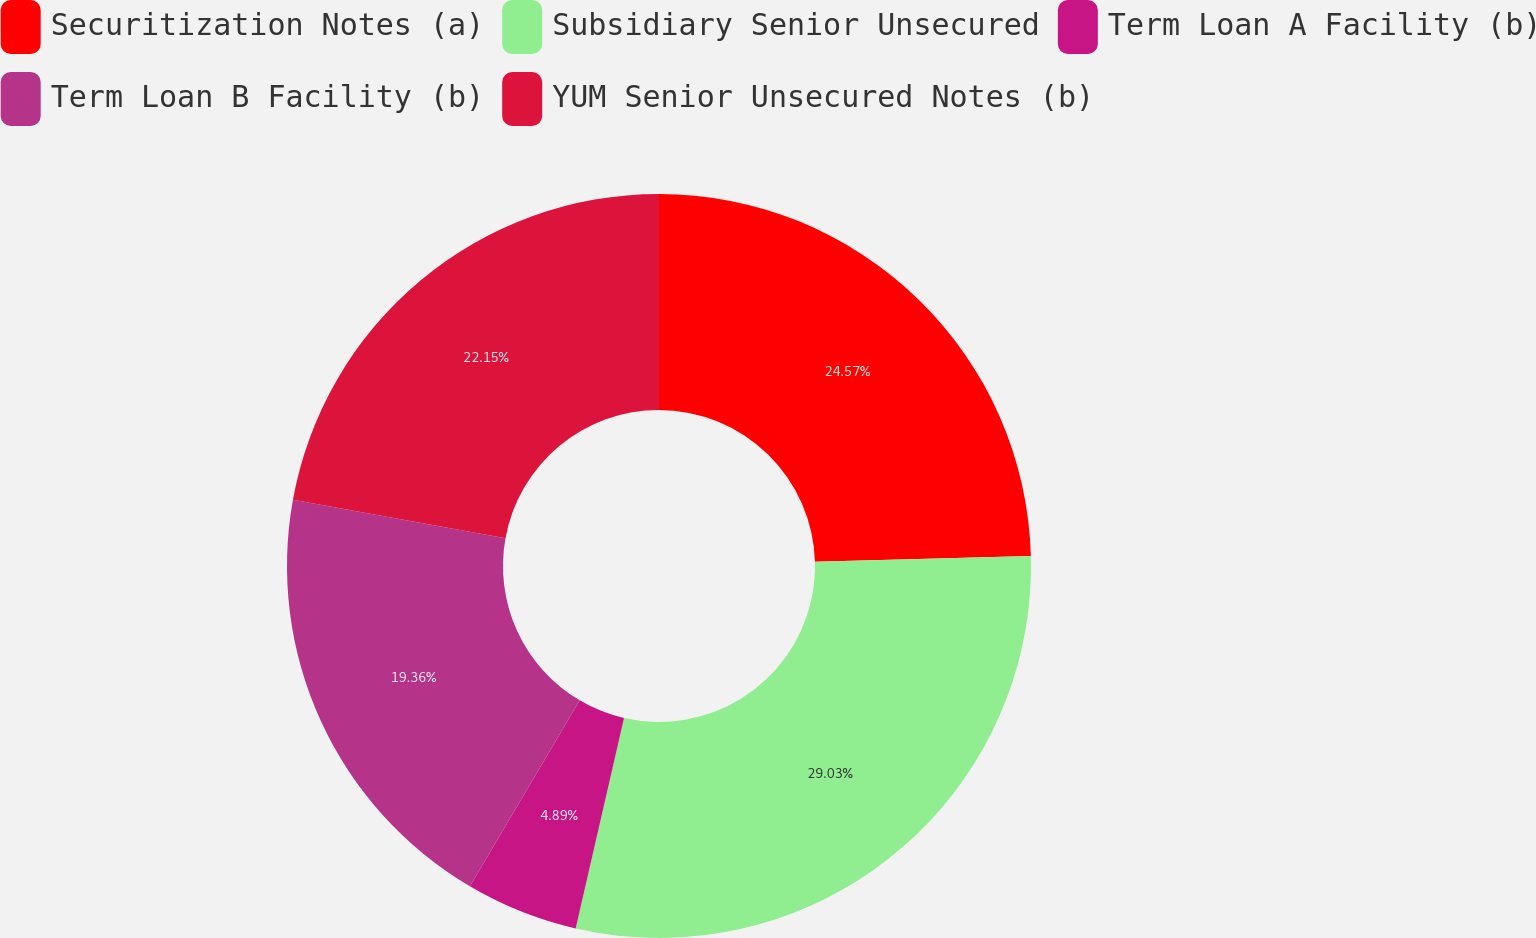Convert chart. <chart><loc_0><loc_0><loc_500><loc_500><pie_chart><fcel>Securitization Notes (a)<fcel>Subsidiary Senior Unsecured<fcel>Term Loan A Facility (b)<fcel>Term Loan B Facility (b)<fcel>YUM Senior Unsecured Notes (b)<nl><fcel>24.57%<fcel>29.02%<fcel>4.89%<fcel>19.36%<fcel>22.15%<nl></chart> 